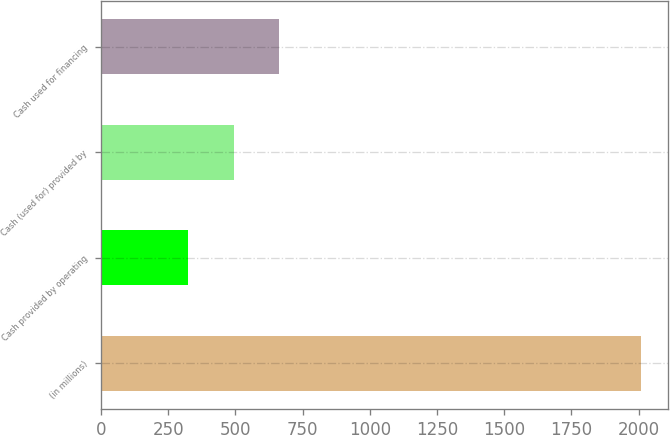Convert chart to OTSL. <chart><loc_0><loc_0><loc_500><loc_500><bar_chart><fcel>(in millions)<fcel>Cash provided by operating<fcel>Cash (used for) provided by<fcel>Cash used for financing<nl><fcel>2010<fcel>325<fcel>493.5<fcel>662<nl></chart> 